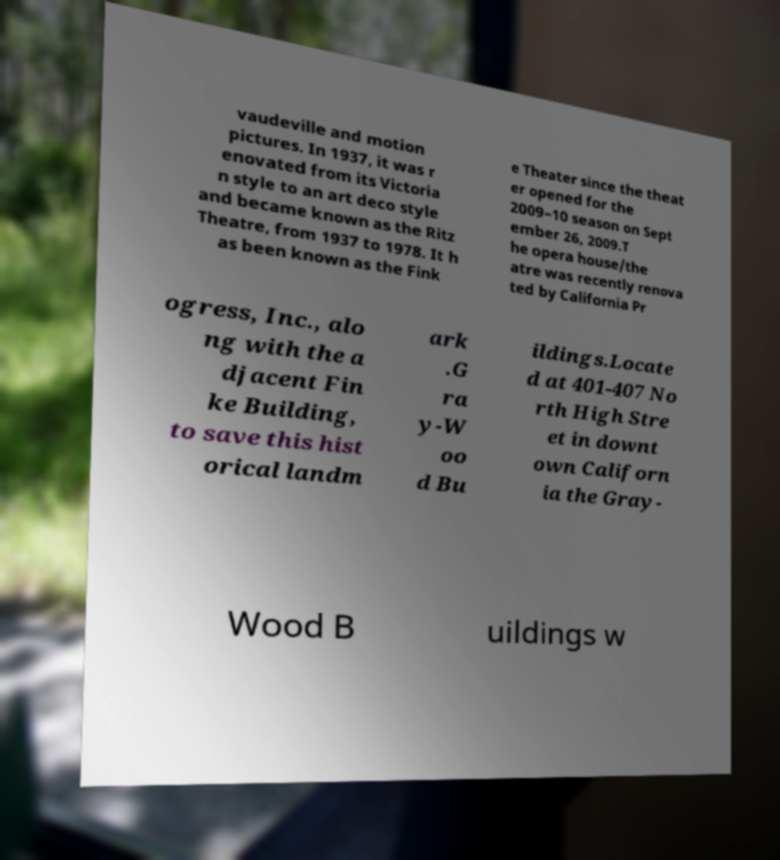Could you extract and type out the text from this image? vaudeville and motion pictures. In 1937, it was r enovated from its Victoria n style to an art deco style and became known as the Ritz Theatre, from 1937 to 1978. It h as been known as the Fink e Theater since the theat er opened for the 2009–10 season on Sept ember 26, 2009.T he opera house/the atre was recently renova ted by California Pr ogress, Inc., alo ng with the a djacent Fin ke Building, to save this hist orical landm ark .G ra y-W oo d Bu ildings.Locate d at 401-407 No rth High Stre et in downt own Californ ia the Gray- Wood B uildings w 